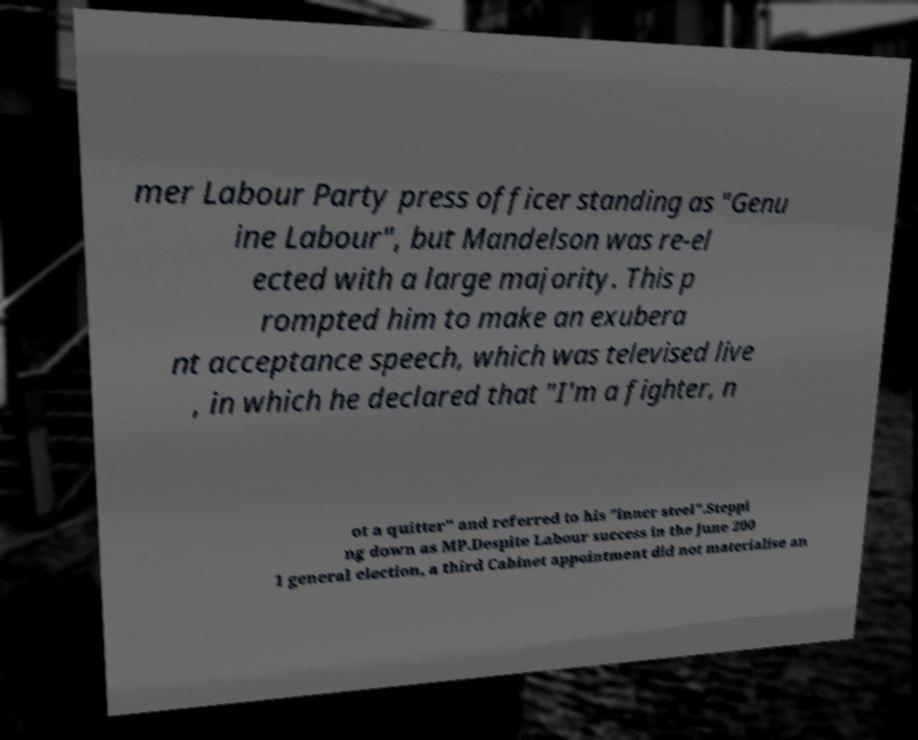What messages or text are displayed in this image? I need them in a readable, typed format. mer Labour Party press officer standing as "Genu ine Labour", but Mandelson was re-el ected with a large majority. This p rompted him to make an exubera nt acceptance speech, which was televised live , in which he declared that "I'm a fighter, n ot a quitter" and referred to his "inner steel".Steppi ng down as MP.Despite Labour success in the June 200 1 general election, a third Cabinet appointment did not materialise an 